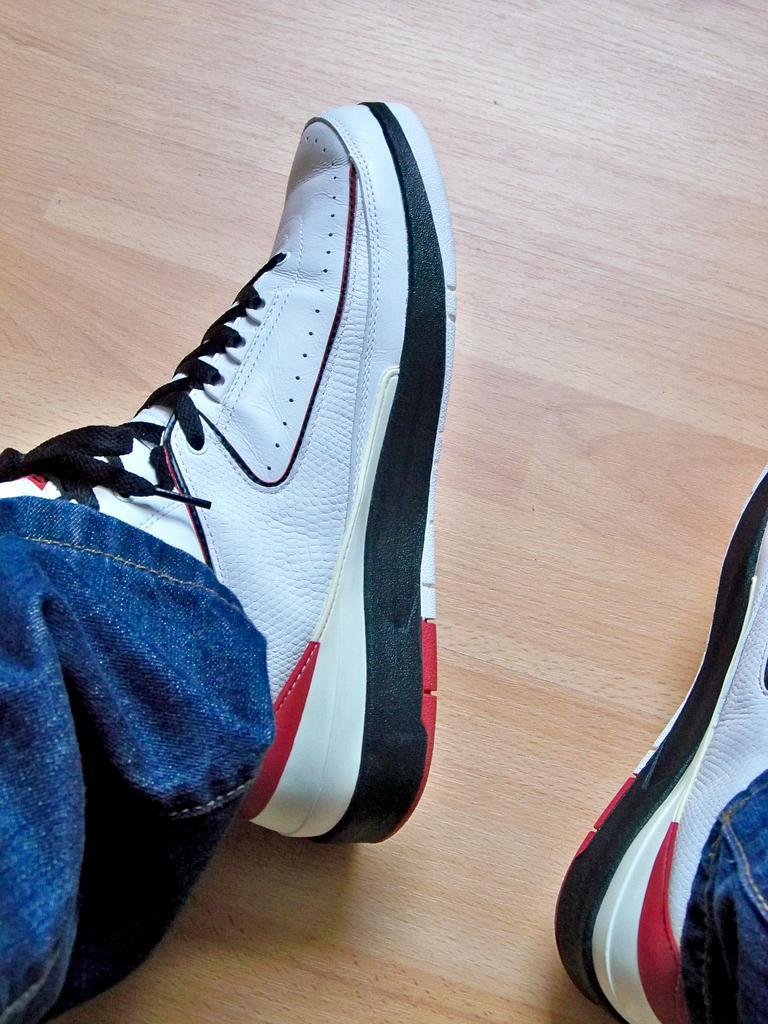Please provide a concise description of this image. Here we can see legs of a person wore shoes. This is floor. 